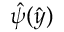Convert formula to latex. <formula><loc_0><loc_0><loc_500><loc_500>\hat { \psi } ( \hat { y } )</formula> 